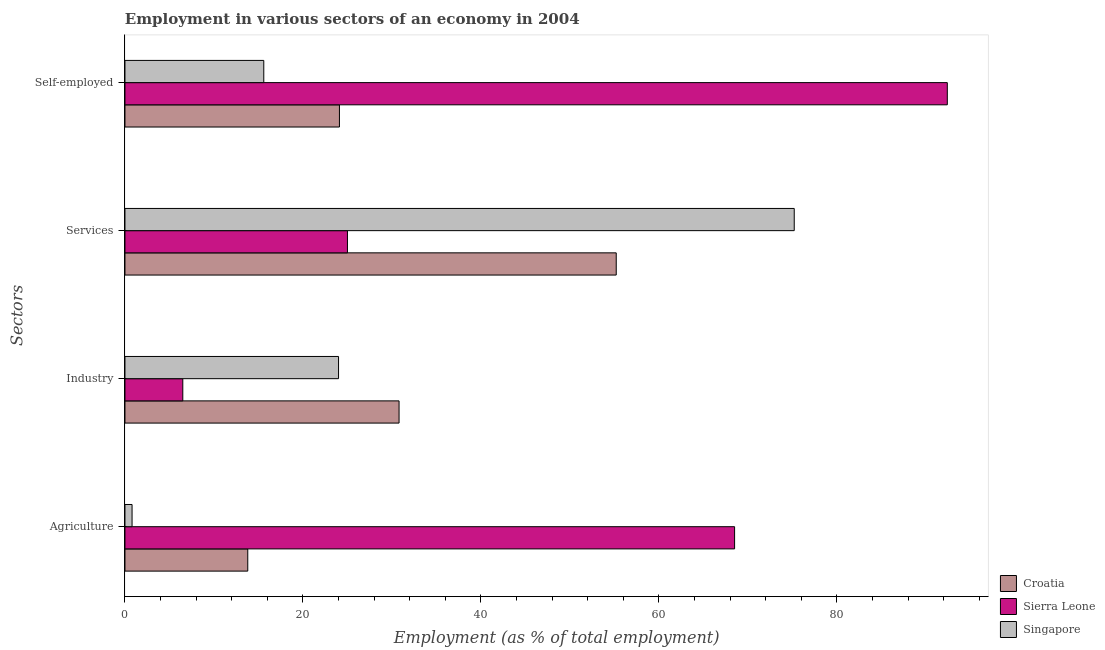How many groups of bars are there?
Ensure brevity in your answer.  4. How many bars are there on the 4th tick from the top?
Ensure brevity in your answer.  3. How many bars are there on the 2nd tick from the bottom?
Your answer should be compact. 3. What is the label of the 2nd group of bars from the top?
Your response must be concise. Services. What is the percentage of workers in agriculture in Singapore?
Ensure brevity in your answer.  0.8. Across all countries, what is the maximum percentage of workers in agriculture?
Give a very brief answer. 68.5. Across all countries, what is the minimum percentage of workers in services?
Keep it short and to the point. 25. In which country was the percentage of self employed workers maximum?
Keep it short and to the point. Sierra Leone. In which country was the percentage of workers in industry minimum?
Make the answer very short. Sierra Leone. What is the total percentage of workers in agriculture in the graph?
Provide a succinct answer. 83.1. What is the difference between the percentage of workers in services in Sierra Leone and that in Singapore?
Offer a very short reply. -50.2. What is the difference between the percentage of workers in industry in Croatia and the percentage of workers in agriculture in Sierra Leone?
Offer a very short reply. -37.7. What is the average percentage of workers in services per country?
Provide a short and direct response. 51.8. What is the difference between the percentage of self employed workers and percentage of workers in agriculture in Croatia?
Make the answer very short. 10.3. In how many countries, is the percentage of self employed workers greater than 56 %?
Provide a succinct answer. 1. What is the ratio of the percentage of self employed workers in Singapore to that in Croatia?
Offer a very short reply. 0.65. Is the percentage of workers in agriculture in Singapore less than that in Croatia?
Offer a terse response. Yes. Is the difference between the percentage of workers in agriculture in Croatia and Sierra Leone greater than the difference between the percentage of self employed workers in Croatia and Sierra Leone?
Give a very brief answer. Yes. What is the difference between the highest and the second highest percentage of workers in agriculture?
Make the answer very short. 54.7. What is the difference between the highest and the lowest percentage of workers in agriculture?
Ensure brevity in your answer.  67.7. Is the sum of the percentage of workers in services in Singapore and Croatia greater than the maximum percentage of workers in industry across all countries?
Your response must be concise. Yes. Is it the case that in every country, the sum of the percentage of workers in services and percentage of workers in industry is greater than the sum of percentage of self employed workers and percentage of workers in agriculture?
Provide a succinct answer. No. What does the 1st bar from the top in Self-employed represents?
Provide a succinct answer. Singapore. What does the 1st bar from the bottom in Industry represents?
Provide a short and direct response. Croatia. Is it the case that in every country, the sum of the percentage of workers in agriculture and percentage of workers in industry is greater than the percentage of workers in services?
Offer a terse response. No. How many countries are there in the graph?
Give a very brief answer. 3. Does the graph contain any zero values?
Give a very brief answer. No. How many legend labels are there?
Ensure brevity in your answer.  3. How are the legend labels stacked?
Provide a succinct answer. Vertical. What is the title of the graph?
Provide a short and direct response. Employment in various sectors of an economy in 2004. What is the label or title of the X-axis?
Offer a very short reply. Employment (as % of total employment). What is the label or title of the Y-axis?
Provide a short and direct response. Sectors. What is the Employment (as % of total employment) in Croatia in Agriculture?
Your answer should be very brief. 13.8. What is the Employment (as % of total employment) in Sierra Leone in Agriculture?
Offer a terse response. 68.5. What is the Employment (as % of total employment) of Singapore in Agriculture?
Provide a short and direct response. 0.8. What is the Employment (as % of total employment) of Croatia in Industry?
Your response must be concise. 30.8. What is the Employment (as % of total employment) in Sierra Leone in Industry?
Keep it short and to the point. 6.5. What is the Employment (as % of total employment) of Singapore in Industry?
Offer a terse response. 24. What is the Employment (as % of total employment) of Croatia in Services?
Keep it short and to the point. 55.2. What is the Employment (as % of total employment) of Singapore in Services?
Make the answer very short. 75.2. What is the Employment (as % of total employment) in Croatia in Self-employed?
Provide a succinct answer. 24.1. What is the Employment (as % of total employment) in Sierra Leone in Self-employed?
Provide a succinct answer. 92.4. What is the Employment (as % of total employment) in Singapore in Self-employed?
Give a very brief answer. 15.6. Across all Sectors, what is the maximum Employment (as % of total employment) in Croatia?
Offer a terse response. 55.2. Across all Sectors, what is the maximum Employment (as % of total employment) of Sierra Leone?
Your answer should be compact. 92.4. Across all Sectors, what is the maximum Employment (as % of total employment) in Singapore?
Your answer should be compact. 75.2. Across all Sectors, what is the minimum Employment (as % of total employment) in Croatia?
Offer a very short reply. 13.8. Across all Sectors, what is the minimum Employment (as % of total employment) of Sierra Leone?
Your answer should be compact. 6.5. Across all Sectors, what is the minimum Employment (as % of total employment) in Singapore?
Your response must be concise. 0.8. What is the total Employment (as % of total employment) in Croatia in the graph?
Provide a short and direct response. 123.9. What is the total Employment (as % of total employment) in Sierra Leone in the graph?
Keep it short and to the point. 192.4. What is the total Employment (as % of total employment) in Singapore in the graph?
Provide a succinct answer. 115.6. What is the difference between the Employment (as % of total employment) of Singapore in Agriculture and that in Industry?
Keep it short and to the point. -23.2. What is the difference between the Employment (as % of total employment) in Croatia in Agriculture and that in Services?
Offer a very short reply. -41.4. What is the difference between the Employment (as % of total employment) of Sierra Leone in Agriculture and that in Services?
Your answer should be very brief. 43.5. What is the difference between the Employment (as % of total employment) in Singapore in Agriculture and that in Services?
Your response must be concise. -74.4. What is the difference between the Employment (as % of total employment) in Sierra Leone in Agriculture and that in Self-employed?
Keep it short and to the point. -23.9. What is the difference between the Employment (as % of total employment) in Singapore in Agriculture and that in Self-employed?
Offer a very short reply. -14.8. What is the difference between the Employment (as % of total employment) in Croatia in Industry and that in Services?
Your answer should be very brief. -24.4. What is the difference between the Employment (as % of total employment) in Sierra Leone in Industry and that in Services?
Provide a succinct answer. -18.5. What is the difference between the Employment (as % of total employment) of Singapore in Industry and that in Services?
Your answer should be compact. -51.2. What is the difference between the Employment (as % of total employment) in Croatia in Industry and that in Self-employed?
Ensure brevity in your answer.  6.7. What is the difference between the Employment (as % of total employment) of Sierra Leone in Industry and that in Self-employed?
Ensure brevity in your answer.  -85.9. What is the difference between the Employment (as % of total employment) of Croatia in Services and that in Self-employed?
Ensure brevity in your answer.  31.1. What is the difference between the Employment (as % of total employment) of Sierra Leone in Services and that in Self-employed?
Give a very brief answer. -67.4. What is the difference between the Employment (as % of total employment) of Singapore in Services and that in Self-employed?
Your response must be concise. 59.6. What is the difference between the Employment (as % of total employment) in Croatia in Agriculture and the Employment (as % of total employment) in Sierra Leone in Industry?
Keep it short and to the point. 7.3. What is the difference between the Employment (as % of total employment) in Croatia in Agriculture and the Employment (as % of total employment) in Singapore in Industry?
Provide a short and direct response. -10.2. What is the difference between the Employment (as % of total employment) of Sierra Leone in Agriculture and the Employment (as % of total employment) of Singapore in Industry?
Offer a very short reply. 44.5. What is the difference between the Employment (as % of total employment) in Croatia in Agriculture and the Employment (as % of total employment) in Sierra Leone in Services?
Provide a short and direct response. -11.2. What is the difference between the Employment (as % of total employment) of Croatia in Agriculture and the Employment (as % of total employment) of Singapore in Services?
Keep it short and to the point. -61.4. What is the difference between the Employment (as % of total employment) in Croatia in Agriculture and the Employment (as % of total employment) in Sierra Leone in Self-employed?
Your response must be concise. -78.6. What is the difference between the Employment (as % of total employment) in Croatia in Agriculture and the Employment (as % of total employment) in Singapore in Self-employed?
Your answer should be compact. -1.8. What is the difference between the Employment (as % of total employment) in Sierra Leone in Agriculture and the Employment (as % of total employment) in Singapore in Self-employed?
Your answer should be compact. 52.9. What is the difference between the Employment (as % of total employment) of Croatia in Industry and the Employment (as % of total employment) of Singapore in Services?
Your answer should be very brief. -44.4. What is the difference between the Employment (as % of total employment) of Sierra Leone in Industry and the Employment (as % of total employment) of Singapore in Services?
Your answer should be compact. -68.7. What is the difference between the Employment (as % of total employment) in Croatia in Industry and the Employment (as % of total employment) in Sierra Leone in Self-employed?
Your answer should be very brief. -61.6. What is the difference between the Employment (as % of total employment) in Sierra Leone in Industry and the Employment (as % of total employment) in Singapore in Self-employed?
Your answer should be compact. -9.1. What is the difference between the Employment (as % of total employment) in Croatia in Services and the Employment (as % of total employment) in Sierra Leone in Self-employed?
Make the answer very short. -37.2. What is the difference between the Employment (as % of total employment) in Croatia in Services and the Employment (as % of total employment) in Singapore in Self-employed?
Make the answer very short. 39.6. What is the average Employment (as % of total employment) in Croatia per Sectors?
Make the answer very short. 30.98. What is the average Employment (as % of total employment) of Sierra Leone per Sectors?
Make the answer very short. 48.1. What is the average Employment (as % of total employment) of Singapore per Sectors?
Your answer should be compact. 28.9. What is the difference between the Employment (as % of total employment) in Croatia and Employment (as % of total employment) in Sierra Leone in Agriculture?
Offer a terse response. -54.7. What is the difference between the Employment (as % of total employment) of Sierra Leone and Employment (as % of total employment) of Singapore in Agriculture?
Give a very brief answer. 67.7. What is the difference between the Employment (as % of total employment) of Croatia and Employment (as % of total employment) of Sierra Leone in Industry?
Provide a succinct answer. 24.3. What is the difference between the Employment (as % of total employment) in Sierra Leone and Employment (as % of total employment) in Singapore in Industry?
Keep it short and to the point. -17.5. What is the difference between the Employment (as % of total employment) of Croatia and Employment (as % of total employment) of Sierra Leone in Services?
Your answer should be very brief. 30.2. What is the difference between the Employment (as % of total employment) of Sierra Leone and Employment (as % of total employment) of Singapore in Services?
Provide a succinct answer. -50.2. What is the difference between the Employment (as % of total employment) of Croatia and Employment (as % of total employment) of Sierra Leone in Self-employed?
Provide a short and direct response. -68.3. What is the difference between the Employment (as % of total employment) in Croatia and Employment (as % of total employment) in Singapore in Self-employed?
Your response must be concise. 8.5. What is the difference between the Employment (as % of total employment) of Sierra Leone and Employment (as % of total employment) of Singapore in Self-employed?
Provide a short and direct response. 76.8. What is the ratio of the Employment (as % of total employment) of Croatia in Agriculture to that in Industry?
Provide a succinct answer. 0.45. What is the ratio of the Employment (as % of total employment) in Sierra Leone in Agriculture to that in Industry?
Make the answer very short. 10.54. What is the ratio of the Employment (as % of total employment) in Singapore in Agriculture to that in Industry?
Provide a succinct answer. 0.03. What is the ratio of the Employment (as % of total employment) in Croatia in Agriculture to that in Services?
Your response must be concise. 0.25. What is the ratio of the Employment (as % of total employment) in Sierra Leone in Agriculture to that in Services?
Keep it short and to the point. 2.74. What is the ratio of the Employment (as % of total employment) in Singapore in Agriculture to that in Services?
Your response must be concise. 0.01. What is the ratio of the Employment (as % of total employment) in Croatia in Agriculture to that in Self-employed?
Your answer should be compact. 0.57. What is the ratio of the Employment (as % of total employment) of Sierra Leone in Agriculture to that in Self-employed?
Give a very brief answer. 0.74. What is the ratio of the Employment (as % of total employment) in Singapore in Agriculture to that in Self-employed?
Make the answer very short. 0.05. What is the ratio of the Employment (as % of total employment) of Croatia in Industry to that in Services?
Your answer should be compact. 0.56. What is the ratio of the Employment (as % of total employment) of Sierra Leone in Industry to that in Services?
Offer a terse response. 0.26. What is the ratio of the Employment (as % of total employment) of Singapore in Industry to that in Services?
Make the answer very short. 0.32. What is the ratio of the Employment (as % of total employment) in Croatia in Industry to that in Self-employed?
Provide a short and direct response. 1.28. What is the ratio of the Employment (as % of total employment) of Sierra Leone in Industry to that in Self-employed?
Provide a short and direct response. 0.07. What is the ratio of the Employment (as % of total employment) in Singapore in Industry to that in Self-employed?
Your answer should be very brief. 1.54. What is the ratio of the Employment (as % of total employment) of Croatia in Services to that in Self-employed?
Ensure brevity in your answer.  2.29. What is the ratio of the Employment (as % of total employment) of Sierra Leone in Services to that in Self-employed?
Offer a terse response. 0.27. What is the ratio of the Employment (as % of total employment) of Singapore in Services to that in Self-employed?
Provide a short and direct response. 4.82. What is the difference between the highest and the second highest Employment (as % of total employment) in Croatia?
Offer a very short reply. 24.4. What is the difference between the highest and the second highest Employment (as % of total employment) in Sierra Leone?
Provide a short and direct response. 23.9. What is the difference between the highest and the second highest Employment (as % of total employment) in Singapore?
Offer a very short reply. 51.2. What is the difference between the highest and the lowest Employment (as % of total employment) in Croatia?
Offer a very short reply. 41.4. What is the difference between the highest and the lowest Employment (as % of total employment) of Sierra Leone?
Offer a very short reply. 85.9. What is the difference between the highest and the lowest Employment (as % of total employment) in Singapore?
Give a very brief answer. 74.4. 